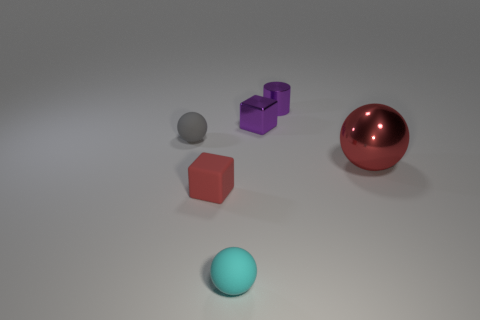What number of other things are the same material as the small cyan ball?
Your answer should be compact. 2. There is a small object right of the tiny purple shiny block; does it have the same shape as the rubber object left of the red matte thing?
Give a very brief answer. No. There is a tiny rubber cube in front of the purple object that is in front of the small shiny object that is behind the small purple cube; what is its color?
Your response must be concise. Red. What number of other objects are the same color as the small matte block?
Give a very brief answer. 1. Is the number of small cyan spheres less than the number of large brown rubber objects?
Provide a succinct answer. No. The metal thing that is both left of the large red shiny ball and in front of the small purple shiny cylinder is what color?
Offer a very short reply. Purple. What is the material of the large red thing that is the same shape as the gray rubber object?
Provide a short and direct response. Metal. Is there any other thing that is the same size as the red shiny sphere?
Provide a succinct answer. No. Are there more red spheres than large cyan metallic cubes?
Your answer should be compact. Yes. There is a metallic object that is both to the right of the tiny purple cube and in front of the metallic cylinder; what is its size?
Your response must be concise. Large. 